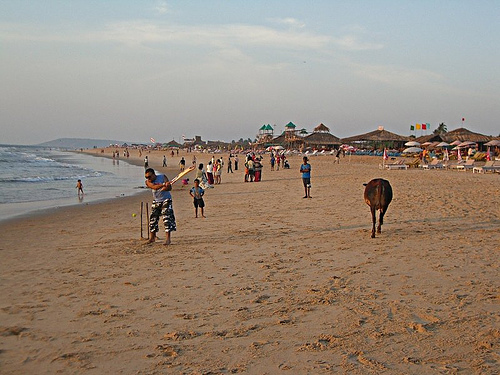<image>What animals are in the water on the beach? I am not sure which animals are in the water on the beach. It could be a cow, a horse, a dog, humans or there could be no animals. What color umbrella can be seen in the background? I am not sure about the umbrella color in the background. It can be either white or blue. What animals are in the water on the beach? I don't know what animals are in the water on the beach. It can be seen cows, horses, dogs or humans. What color umbrella can be seen in the background? I don't know what color umbrella can be seen in the background. It can be either blue or white. 